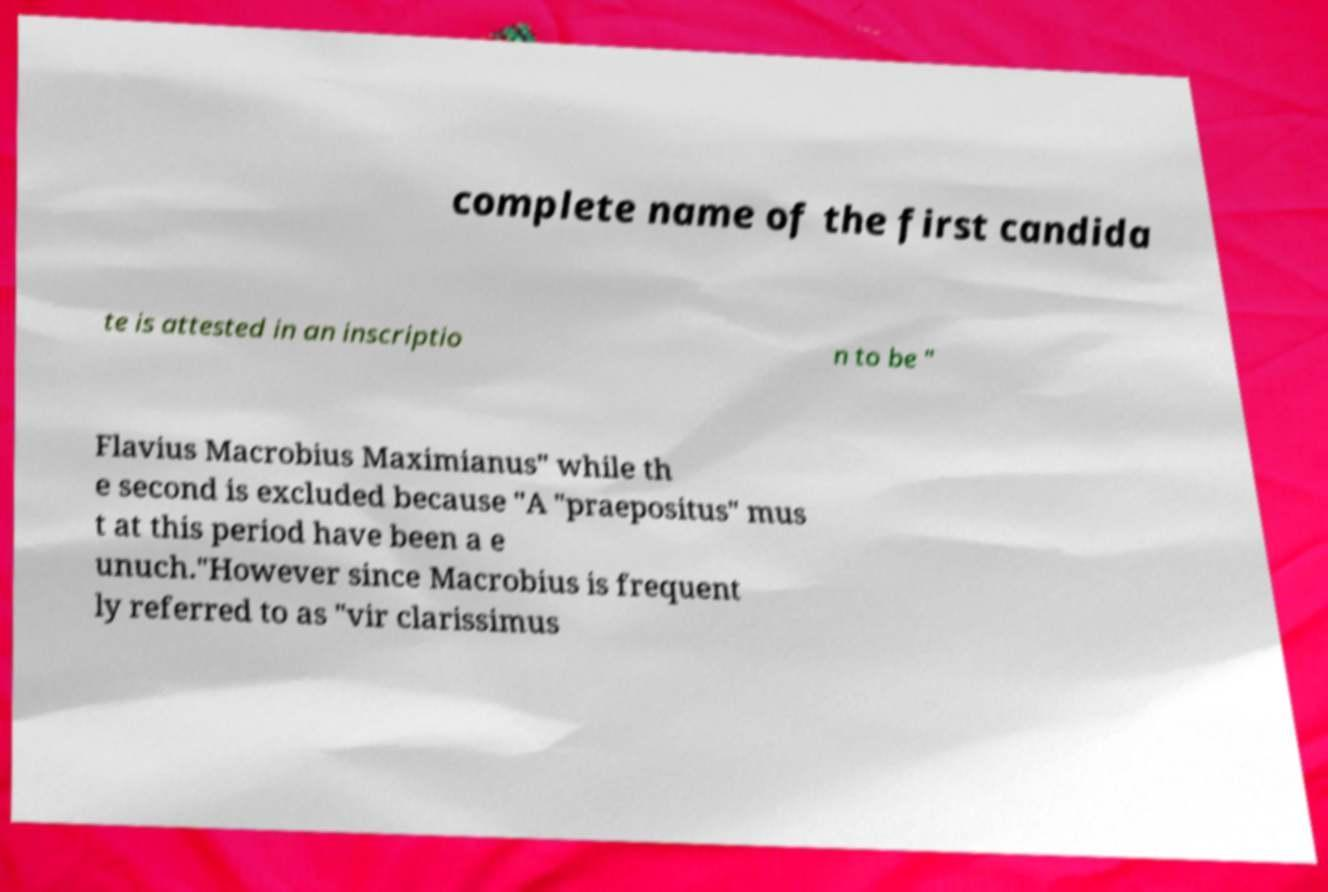Could you assist in decoding the text presented in this image and type it out clearly? complete name of the first candida te is attested in an inscriptio n to be " Flavius Macrobius Maximianus" while th e second is excluded because "A "praepositus" mus t at this period have been a e unuch."However since Macrobius is frequent ly referred to as "vir clarissimus 